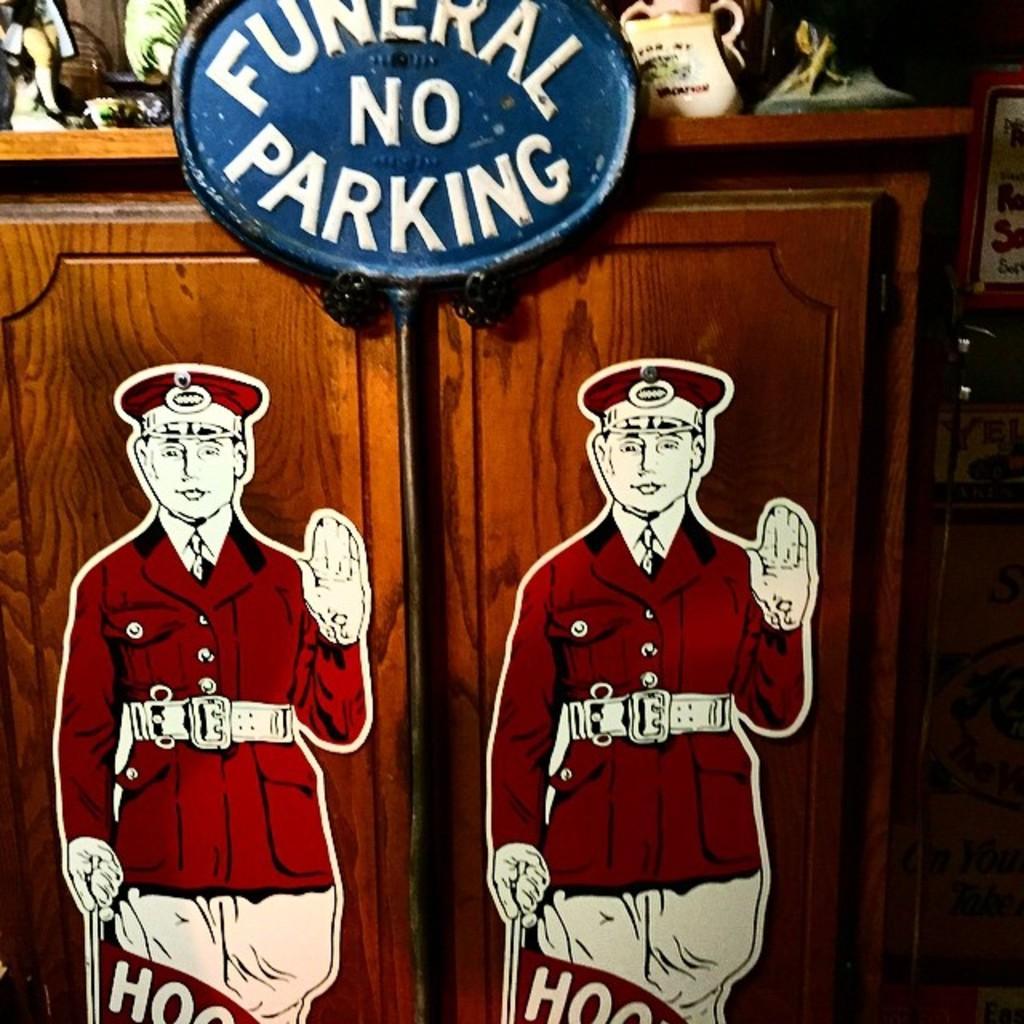Can you describe this image briefly? We can see stickers of a person on the cupboard doors and there is a pole. At the top there are objects on a cupboard table and on the right side there are objects. 